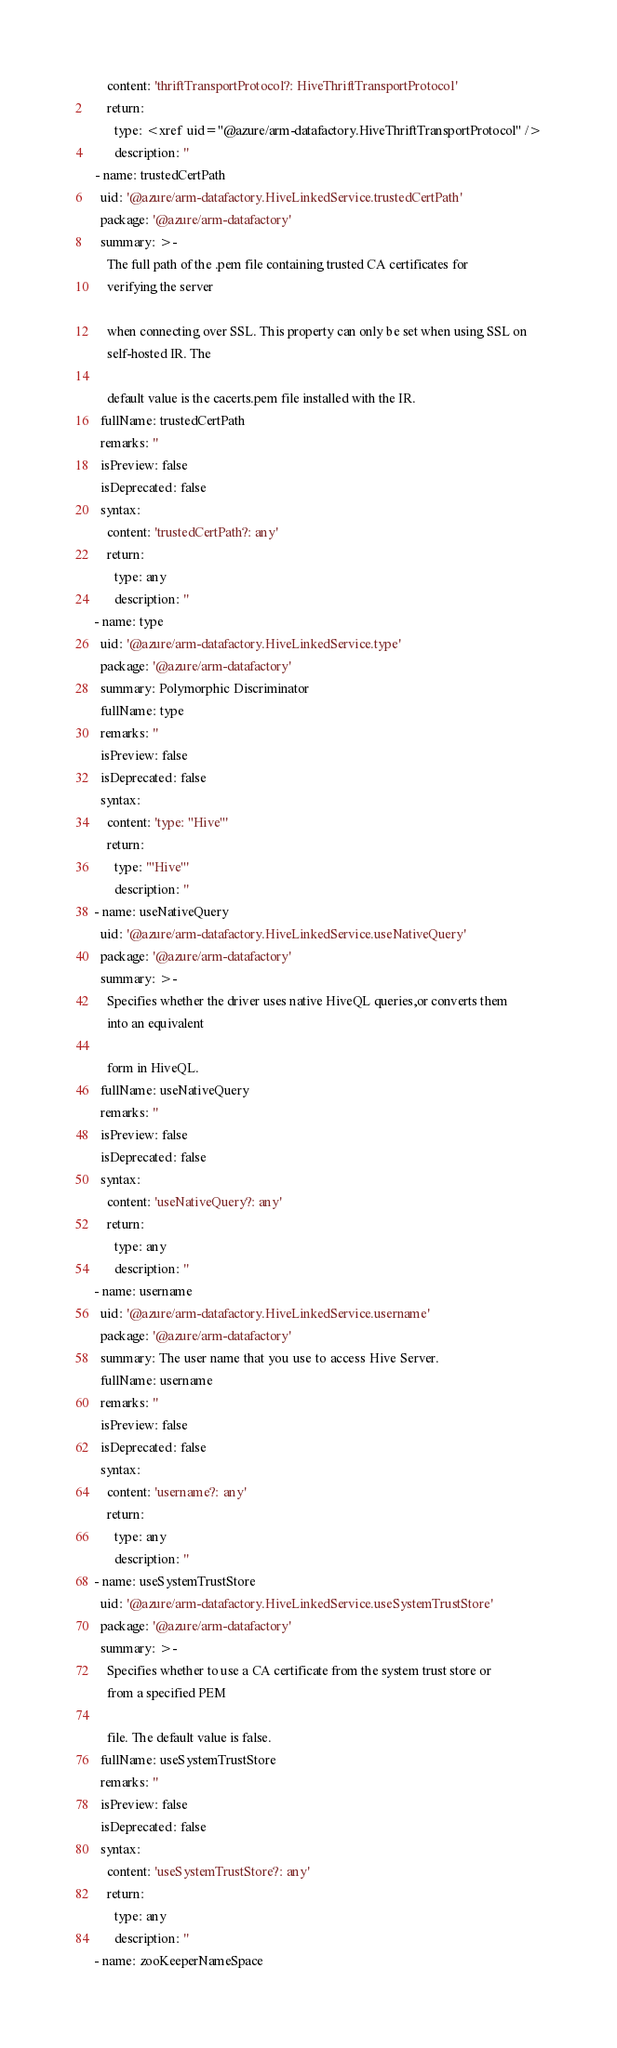Convert code to text. <code><loc_0><loc_0><loc_500><loc_500><_YAML_>      content: 'thriftTransportProtocol?: HiveThriftTransportProtocol'
      return:
        type: <xref uid="@azure/arm-datafactory.HiveThriftTransportProtocol" />
        description: ''
  - name: trustedCertPath
    uid: '@azure/arm-datafactory.HiveLinkedService.trustedCertPath'
    package: '@azure/arm-datafactory'
    summary: >-
      The full path of the .pem file containing trusted CA certificates for
      verifying the server

      when connecting over SSL. This property can only be set when using SSL on
      self-hosted IR. The

      default value is the cacerts.pem file installed with the IR.
    fullName: trustedCertPath
    remarks: ''
    isPreview: false
    isDeprecated: false
    syntax:
      content: 'trustedCertPath?: any'
      return:
        type: any
        description: ''
  - name: type
    uid: '@azure/arm-datafactory.HiveLinkedService.type'
    package: '@azure/arm-datafactory'
    summary: Polymorphic Discriminator
    fullName: type
    remarks: ''
    isPreview: false
    isDeprecated: false
    syntax:
      content: 'type: "Hive"'
      return:
        type: '"Hive"'
        description: ''
  - name: useNativeQuery
    uid: '@azure/arm-datafactory.HiveLinkedService.useNativeQuery'
    package: '@azure/arm-datafactory'
    summary: >-
      Specifies whether the driver uses native HiveQL queries,or converts them
      into an equivalent

      form in HiveQL.
    fullName: useNativeQuery
    remarks: ''
    isPreview: false
    isDeprecated: false
    syntax:
      content: 'useNativeQuery?: any'
      return:
        type: any
        description: ''
  - name: username
    uid: '@azure/arm-datafactory.HiveLinkedService.username'
    package: '@azure/arm-datafactory'
    summary: The user name that you use to access Hive Server.
    fullName: username
    remarks: ''
    isPreview: false
    isDeprecated: false
    syntax:
      content: 'username?: any'
      return:
        type: any
        description: ''
  - name: useSystemTrustStore
    uid: '@azure/arm-datafactory.HiveLinkedService.useSystemTrustStore'
    package: '@azure/arm-datafactory'
    summary: >-
      Specifies whether to use a CA certificate from the system trust store or
      from a specified PEM

      file. The default value is false.
    fullName: useSystemTrustStore
    remarks: ''
    isPreview: false
    isDeprecated: false
    syntax:
      content: 'useSystemTrustStore?: any'
      return:
        type: any
        description: ''
  - name: zooKeeperNameSpace</code> 